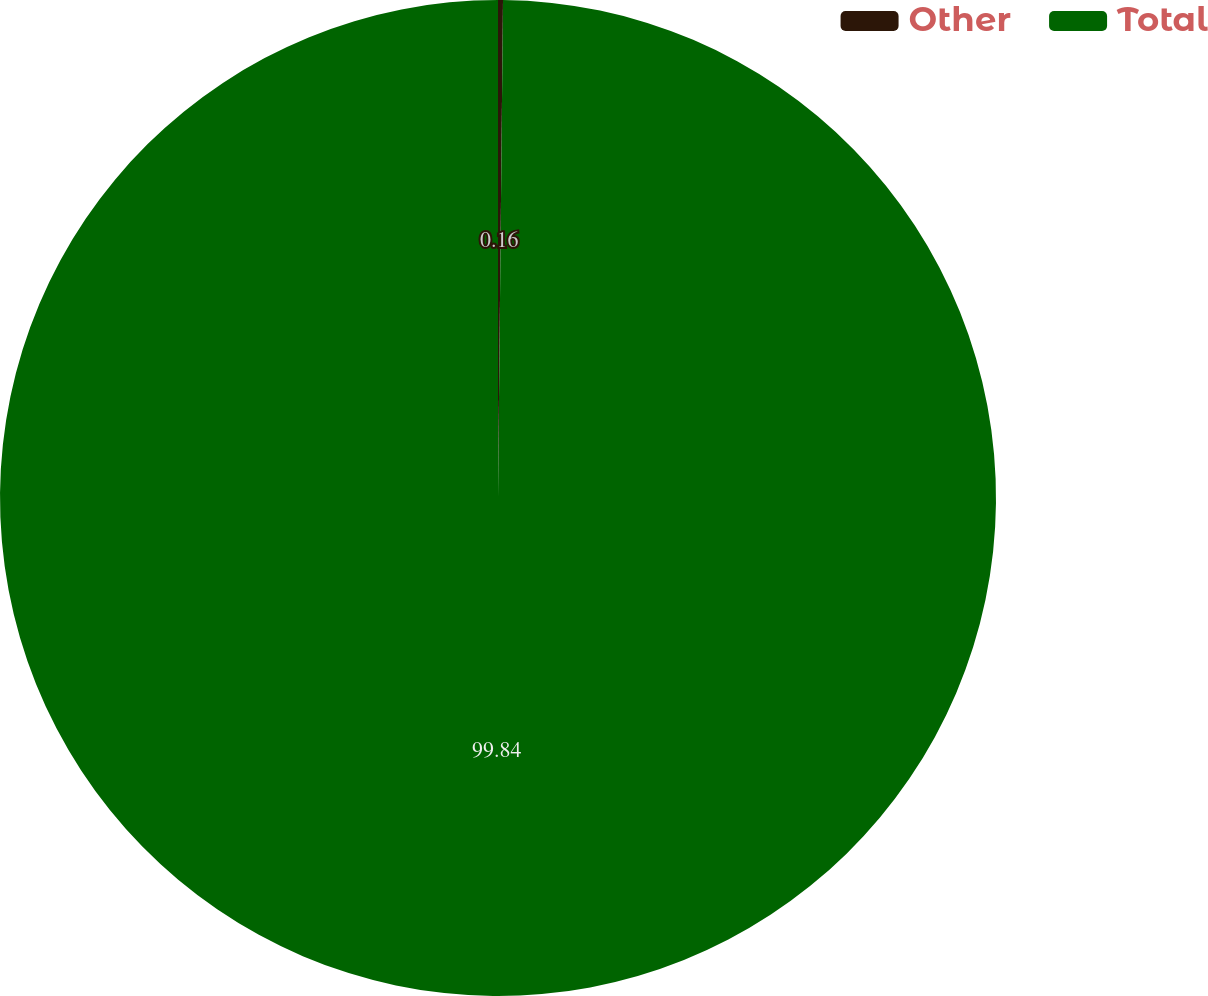Convert chart to OTSL. <chart><loc_0><loc_0><loc_500><loc_500><pie_chart><fcel>Other<fcel>Total<nl><fcel>0.16%<fcel>99.84%<nl></chart> 